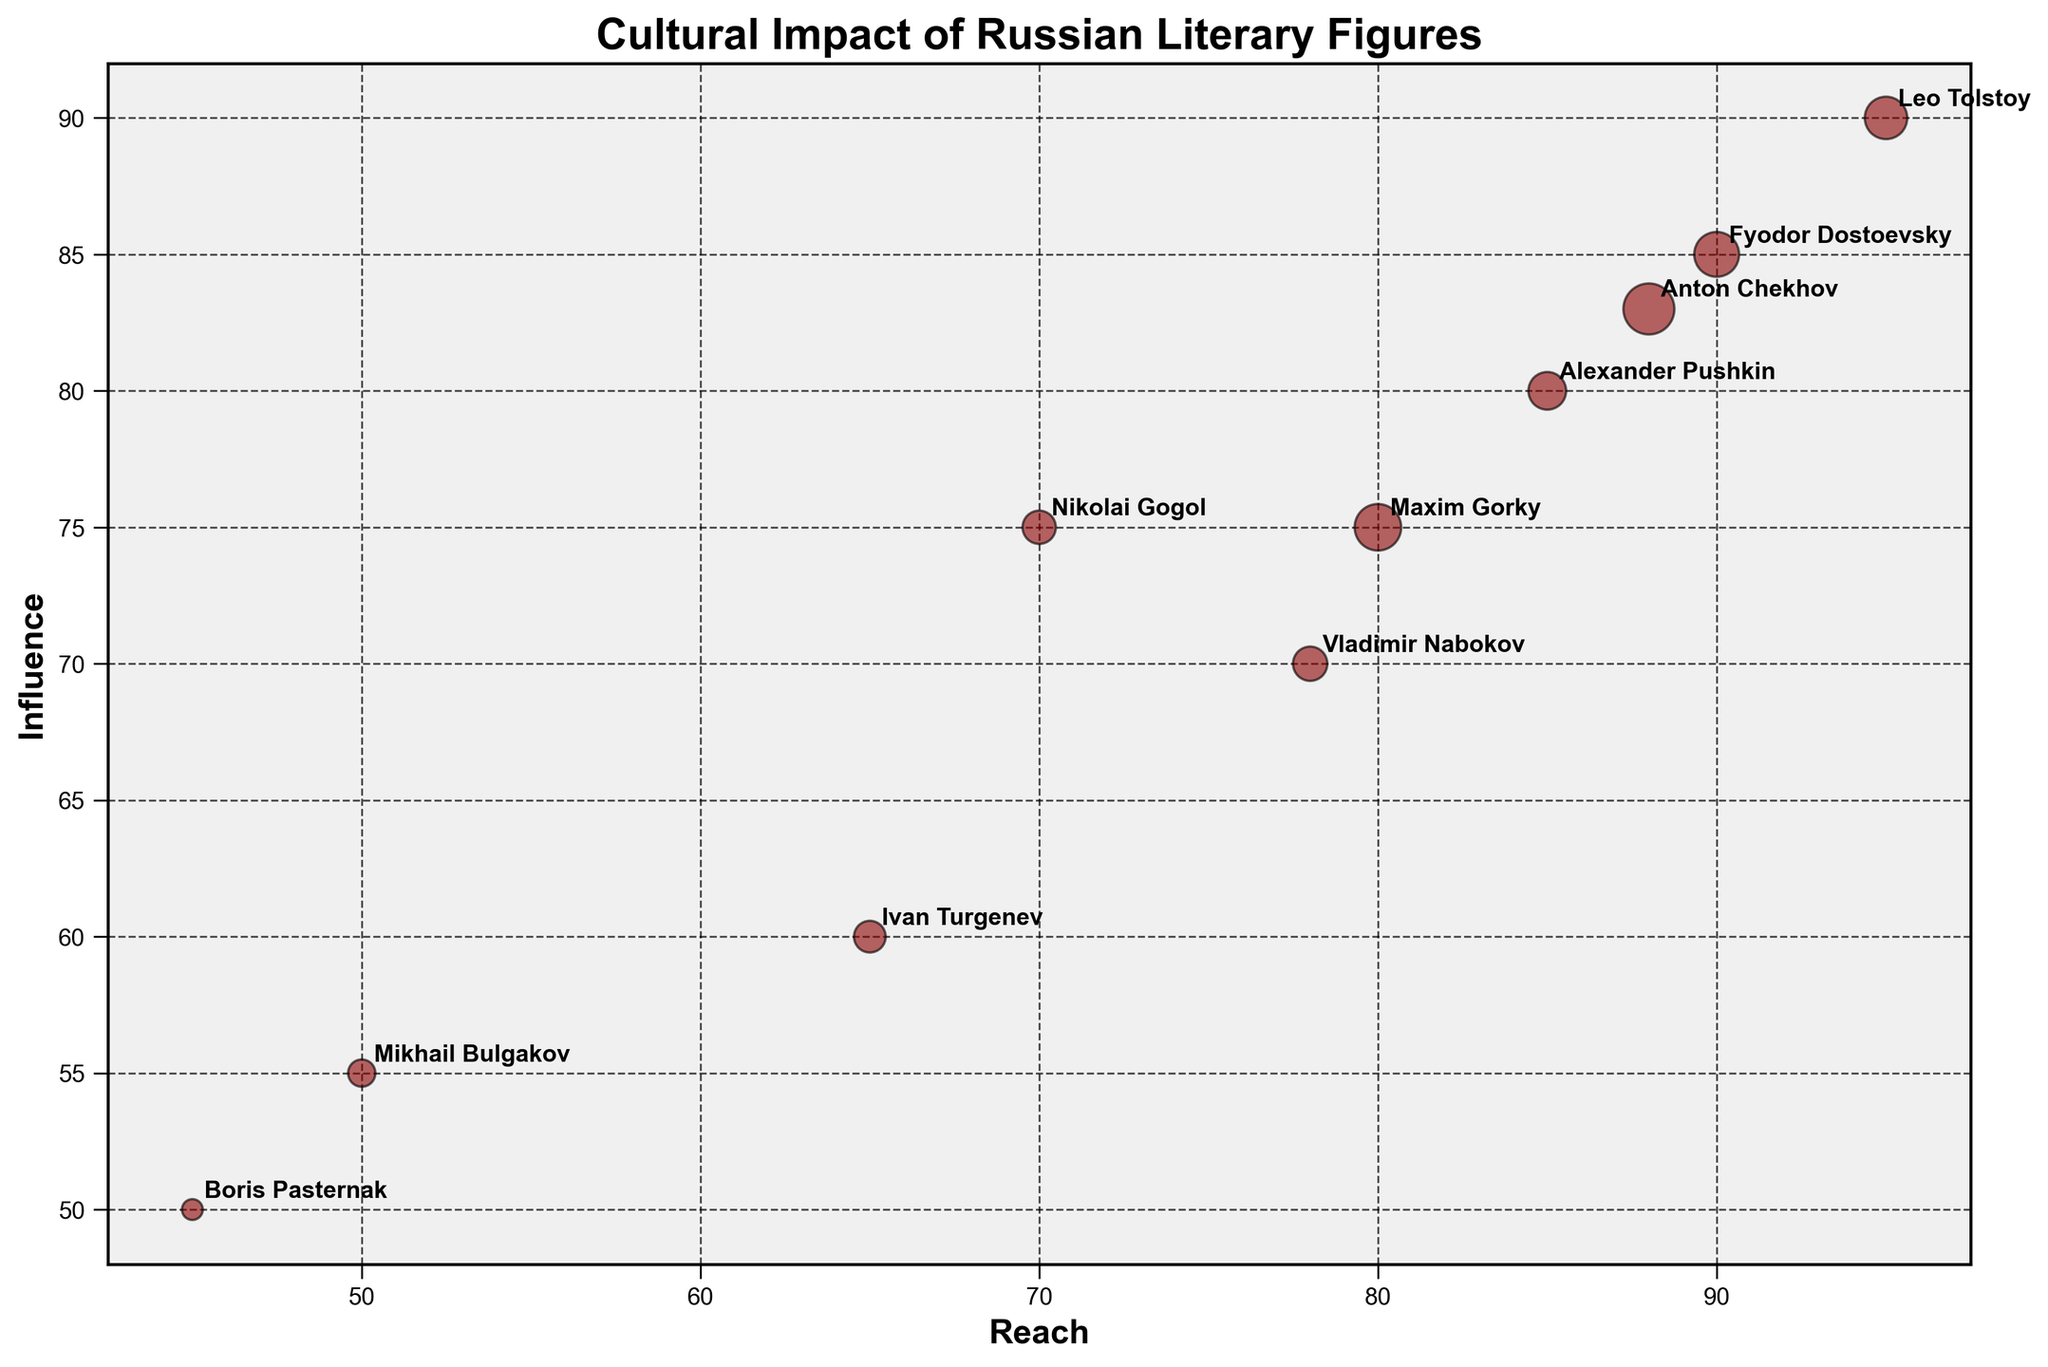What is the bubble chart's title? The bubble chart’s title is clearly displayed at the top of the figure.
Answer: Cultural Impact of Russian Literary Figures Which author has the largest number of published works? The largest bubble corresponds to the author with the highest number of published works. Once we locate the largest bubble, we see that it is annotated with the author Anton Chekhov.
Answer: Anton Chekhov What is the reach value of Leo Tolstoy? Leo Tolstoy’s position on the x-axis shows his 'Reach' value. By finding his bubble and checking its horizontal position, we determine that the reach value is 95.
Answer: 95 Which author has the highest influence value? The author with the highest influence will have their bubble positioned furthest up on the y-axis. Leo Tolstoy’s bubble is closest to the top of the y-axis with an influence value of 90.
Answer: Leo Tolstoy How many authors have a reach value higher than 80? Name them. By checking bubbles positioned to the right of the 80 mark on the x-axis, we see there are four authors: Leo Tolstoy, Fyodor Dostoevsky, Alexander Pushkin, and Anton Chekhov.
Answer: Four, Leo Tolstoy, Fyodor Dostoevsky, Alexander Pushkin, Anton Chekhov Which author has a larger number of published works, Maxim Gorky or Ivan Turgenev? Comparing the sizes of the bubbles annotated with Maxim Gorky and Ivan Turgenev, it’s evident that the size of Maxim Gorky’s bubble is larger.
Answer: Maxim Gorky Given the transparency of the bubbles is inversely related to influence, which author is least transparent? The least transparent bubble (most opaque) represents the author with the highest influence. Observing the transparency levels, Leo Tolstoy’s bubble stands out as least transparent.
Answer: Leo Tolstoy What’s the difference in the number of published works between Fyodor Dostoevsky and Boris Pasternak? Subtracting Boris Pasternak’s number of published works from Fyodor Dostoevsky’s gives us 116 - 25.
Answer: 91 On average, what is the influence value of Anton Chekhov and Vladimir Nabokov? Averaging Anton Chekhov’s and Vladimir Nabokov’s influence values: (83 + 70) / 2 = 76.5.
Answer: 76.5 Which author among Nikolai Gogol and Mikhail Bulgakov has the higher reach value and by how much? By comparing their positions on the x-axis: Nikolai Gogol’s reach is 70 and Mikhail Bulgakov’s reach is 50. The difference is 70 - 50.
Answer: Nikolai Gogol, 20 